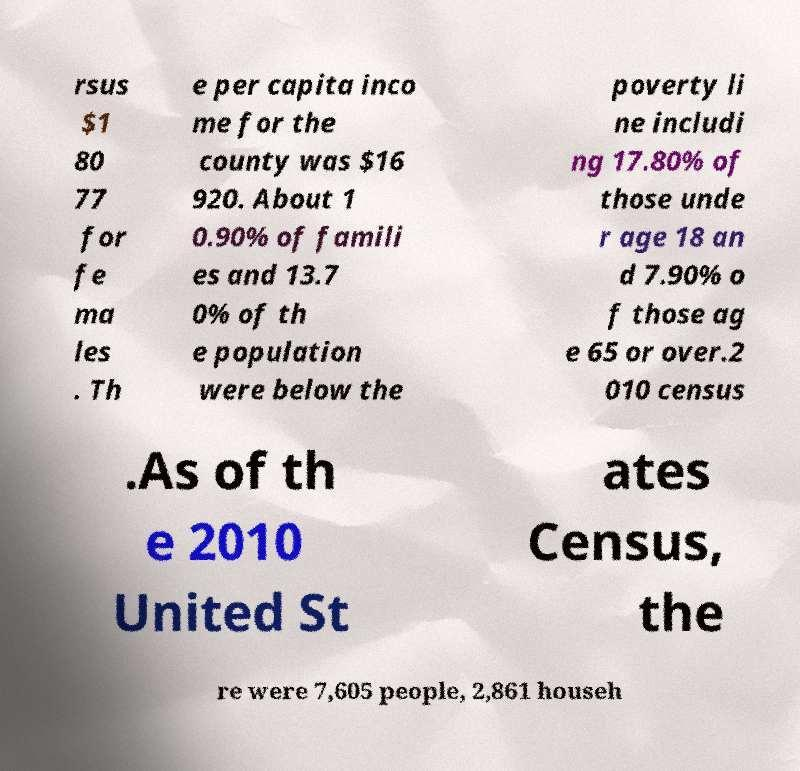Please read and relay the text visible in this image. What does it say? rsus $1 80 77 for fe ma les . Th e per capita inco me for the county was $16 920. About 1 0.90% of famili es and 13.7 0% of th e population were below the poverty li ne includi ng 17.80% of those unde r age 18 an d 7.90% o f those ag e 65 or over.2 010 census .As of th e 2010 United St ates Census, the re were 7,605 people, 2,861 househ 